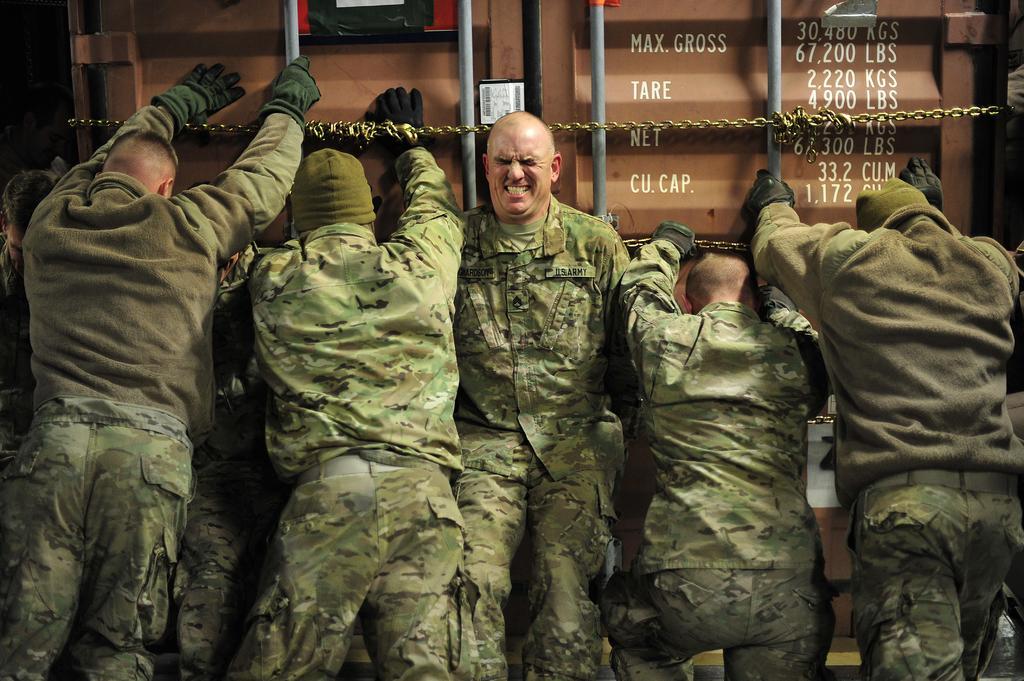Can you describe this image briefly? In this image I can see there are five men pushing a door of a truck and they are wearing army uniform. 